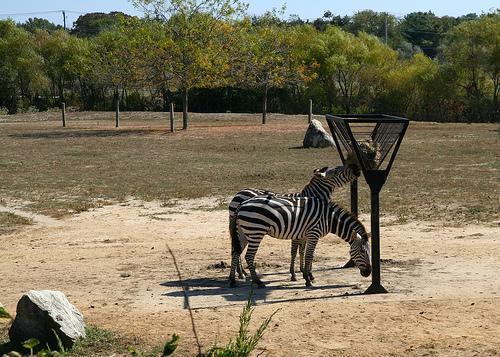How many zebras are shown?
Give a very brief answer. 2. How many zebras are eating from the hay?
Give a very brief answer. 1. 